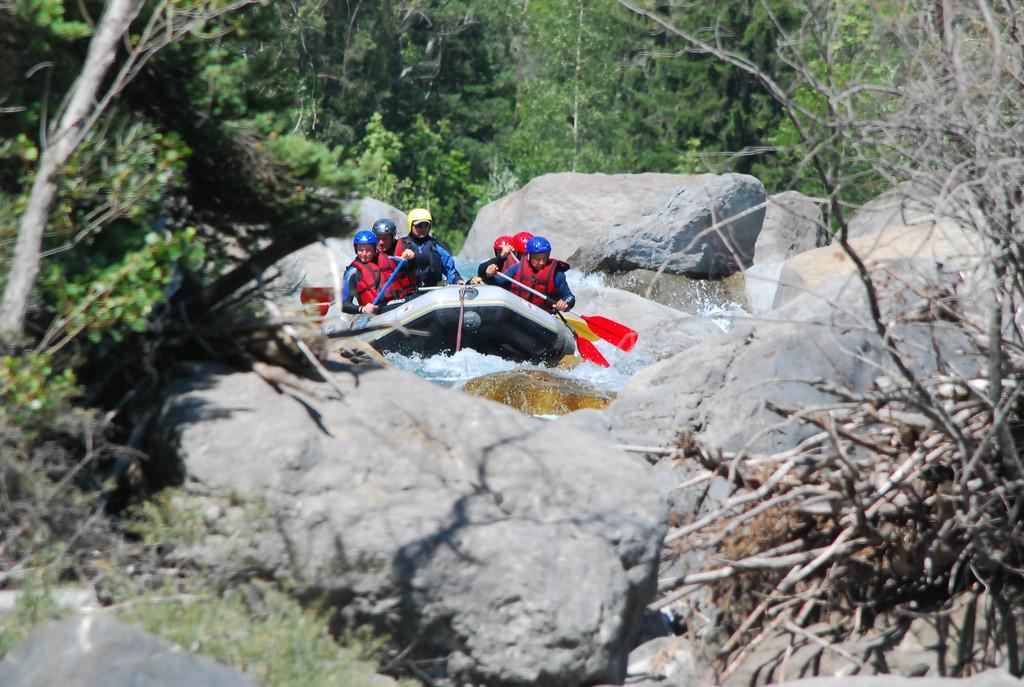Could you give a brief overview of what you see in this image? In this picture we can see a group of friends doing boating. In the front there are stone rock mountain. Behind there are many trees. 